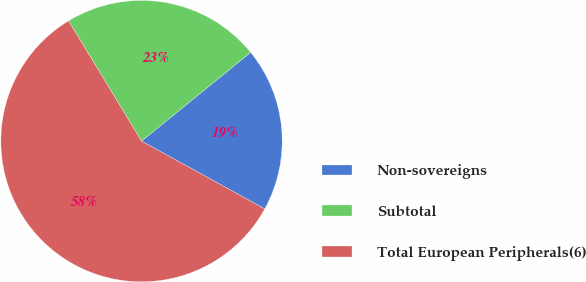<chart> <loc_0><loc_0><loc_500><loc_500><pie_chart><fcel>Non-sovereigns<fcel>Subtotal<fcel>Total European Peripherals(6)<nl><fcel>18.87%<fcel>22.82%<fcel>58.31%<nl></chart> 